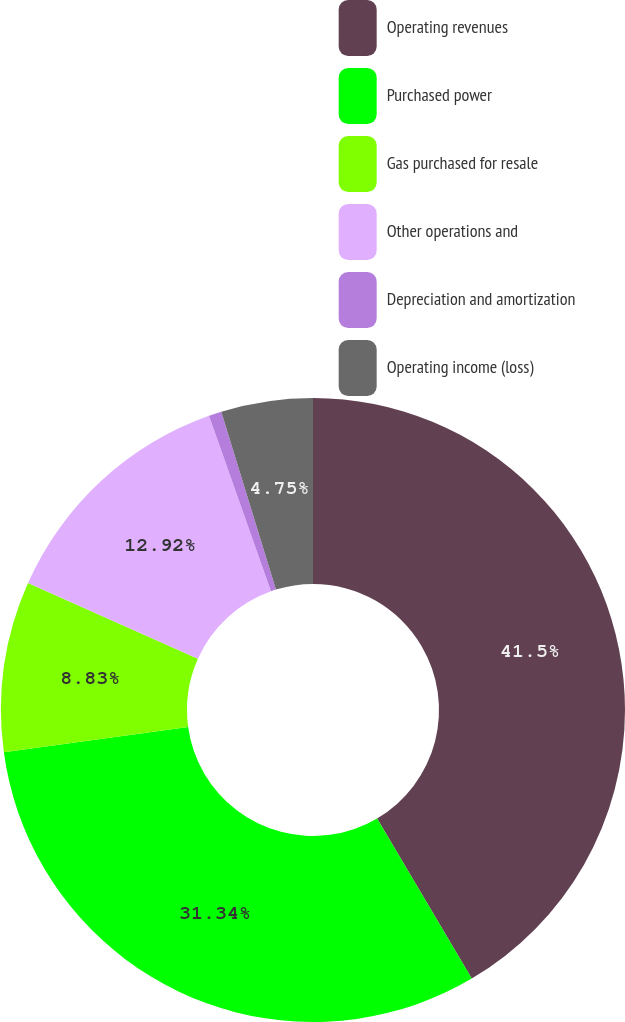<chart> <loc_0><loc_0><loc_500><loc_500><pie_chart><fcel>Operating revenues<fcel>Purchased power<fcel>Gas purchased for resale<fcel>Other operations and<fcel>Depreciation and amortization<fcel>Operating income (loss)<nl><fcel>41.51%<fcel>31.34%<fcel>8.83%<fcel>12.92%<fcel>0.66%<fcel>4.75%<nl></chart> 